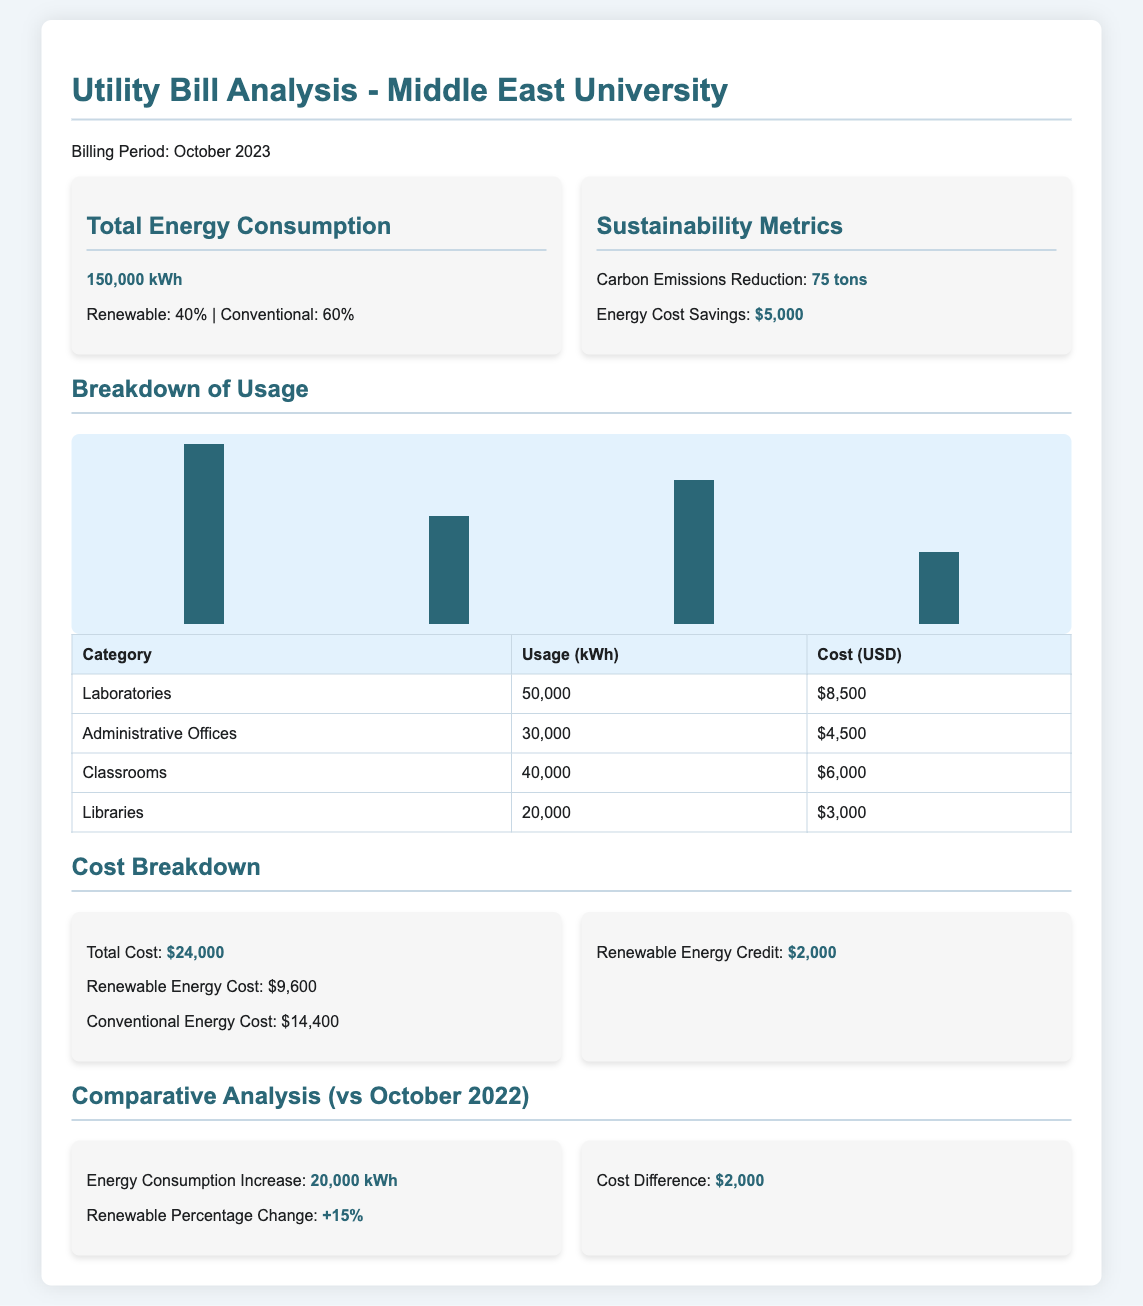What is the total energy consumption? The total energy consumption for October 2023 is provided as a key figure in the document.
Answer: 150,000 kWh What percentage of energy consumption comes from renewable sources? The breakdown of energy consumption indicates that 40% comes from renewable sources.
Answer: 40% What is the carbon emissions reduction? The sustainability metrics highlight the carbon emissions reduction achieved during the billing period.
Answer: 75 tons How much did the university save in energy costs? The document specifies the total energy cost savings achieved, which is an important sustainability metric.
Answer: $5,000 What was the total cost of energy for October 2023? The total cost listed in the cost breakdown section of the document gives the overall expenditure for energy.
Answer: $24,000 What is the renewable energy credit amount? The document includes a specific figure related to renewable energy credits, which is essential for understanding financial incentives.
Answer: $2,000 What was the energy consumption increase compared to October 2022? The comparative analysis section presents a clear figure showing energy consumption changes over the previous year.
Answer: 20,000 kWh What was the renewable percentage change from October 2022? The document provides a percentage indicating the change in renewable energy consumption over the previous year.
Answer: +15% How much did conventional energy cost in October 2023? The cost breakdown section specifies the expenditure related to conventional energy sources specifically.
Answer: $14,400 